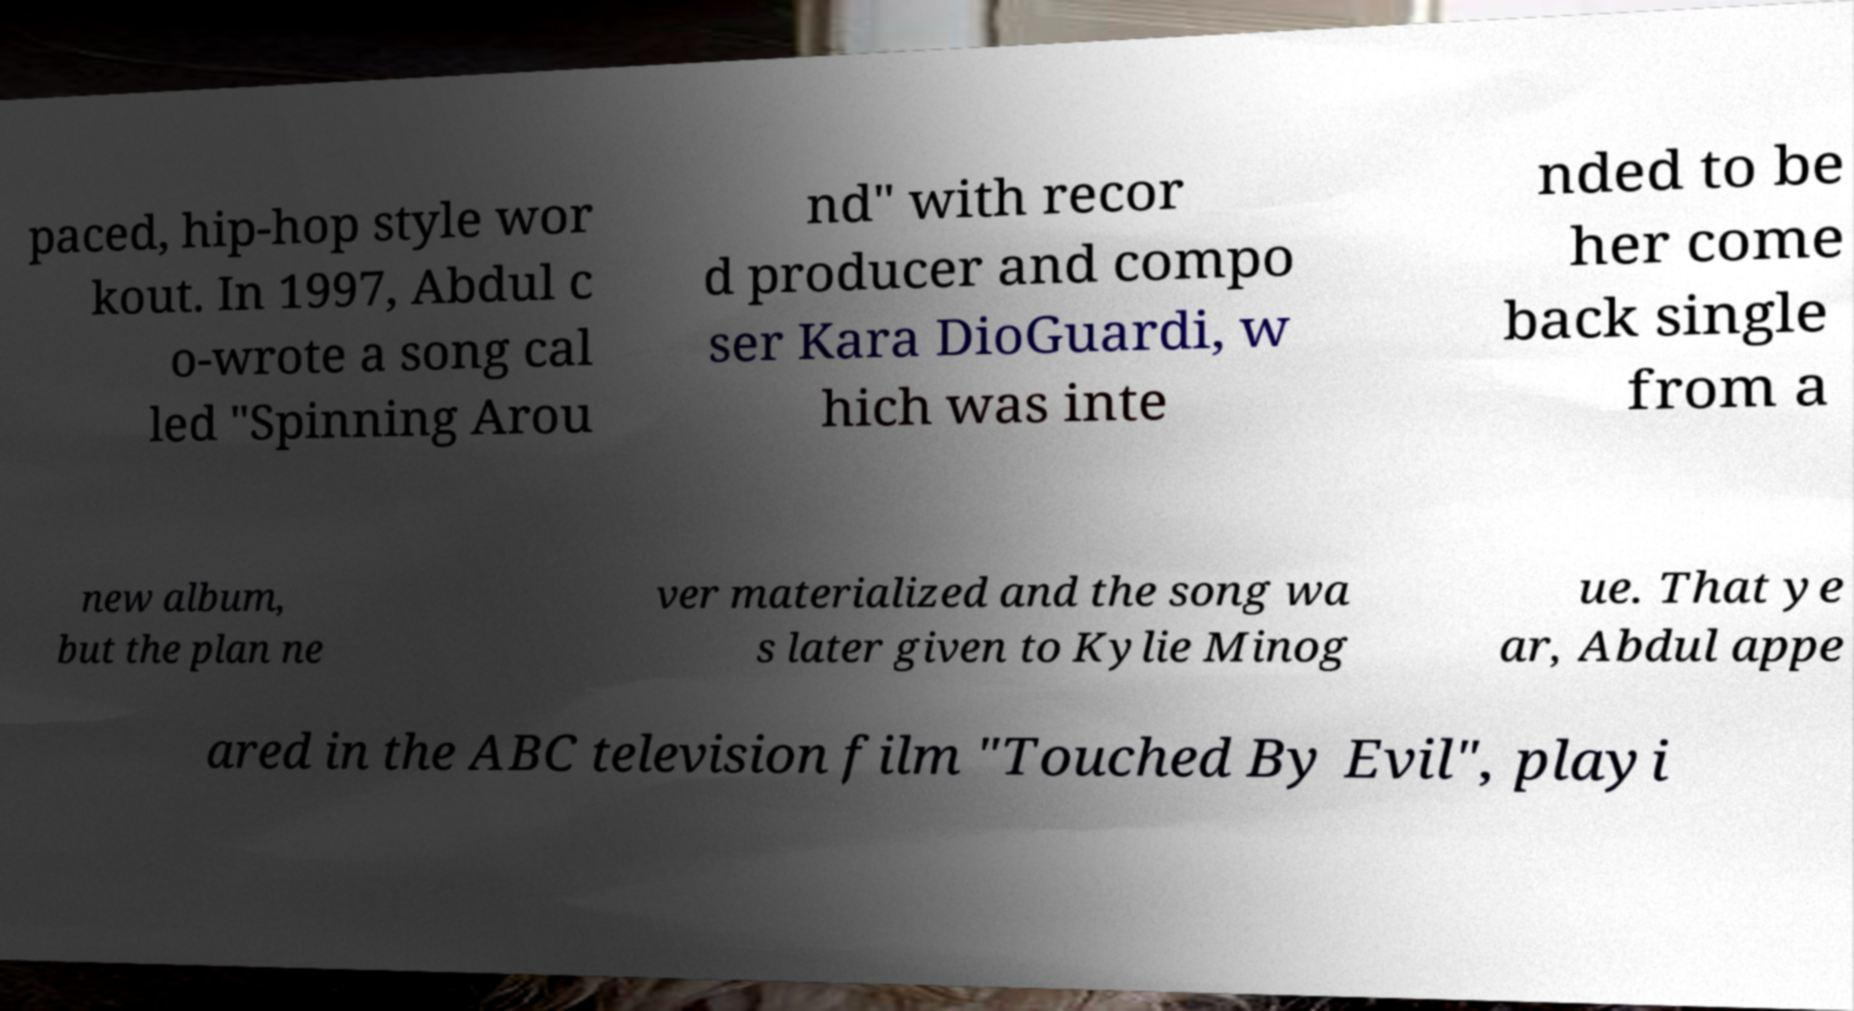What messages or text are displayed in this image? I need them in a readable, typed format. paced, hip-hop style wor kout. In 1997, Abdul c o-wrote a song cal led "Spinning Arou nd" with recor d producer and compo ser Kara DioGuardi, w hich was inte nded to be her come back single from a new album, but the plan ne ver materialized and the song wa s later given to Kylie Minog ue. That ye ar, Abdul appe ared in the ABC television film "Touched By Evil", playi 